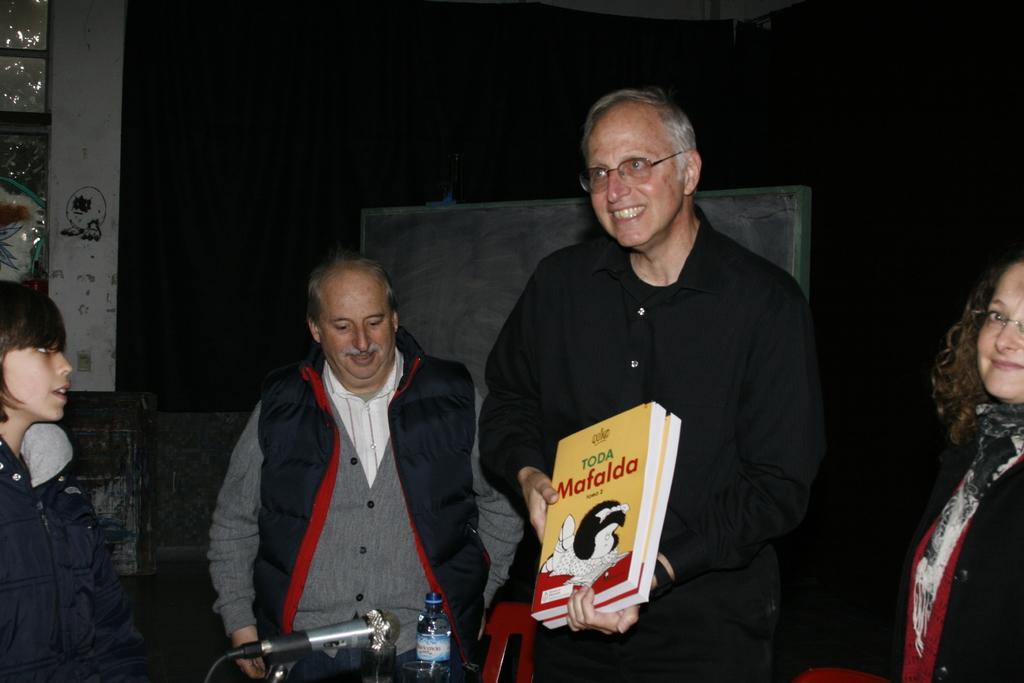What are the people in the image doing? The people in the image are standing. What is the man holding in the image? The man is holding books. What object is in front of the people? There is a microphone in front of the people. What is placed in front of the people along with the microphone? There is a bottle in front of the people. What can be seen in the background of the image? The background of the image includes a board. How would you describe the lighting in the image? The background is dark. Where is the faucet located in the image? There is no faucet present in the image. What type of wire is being used by the people in the image? There is no wire being used by the people in the image. 